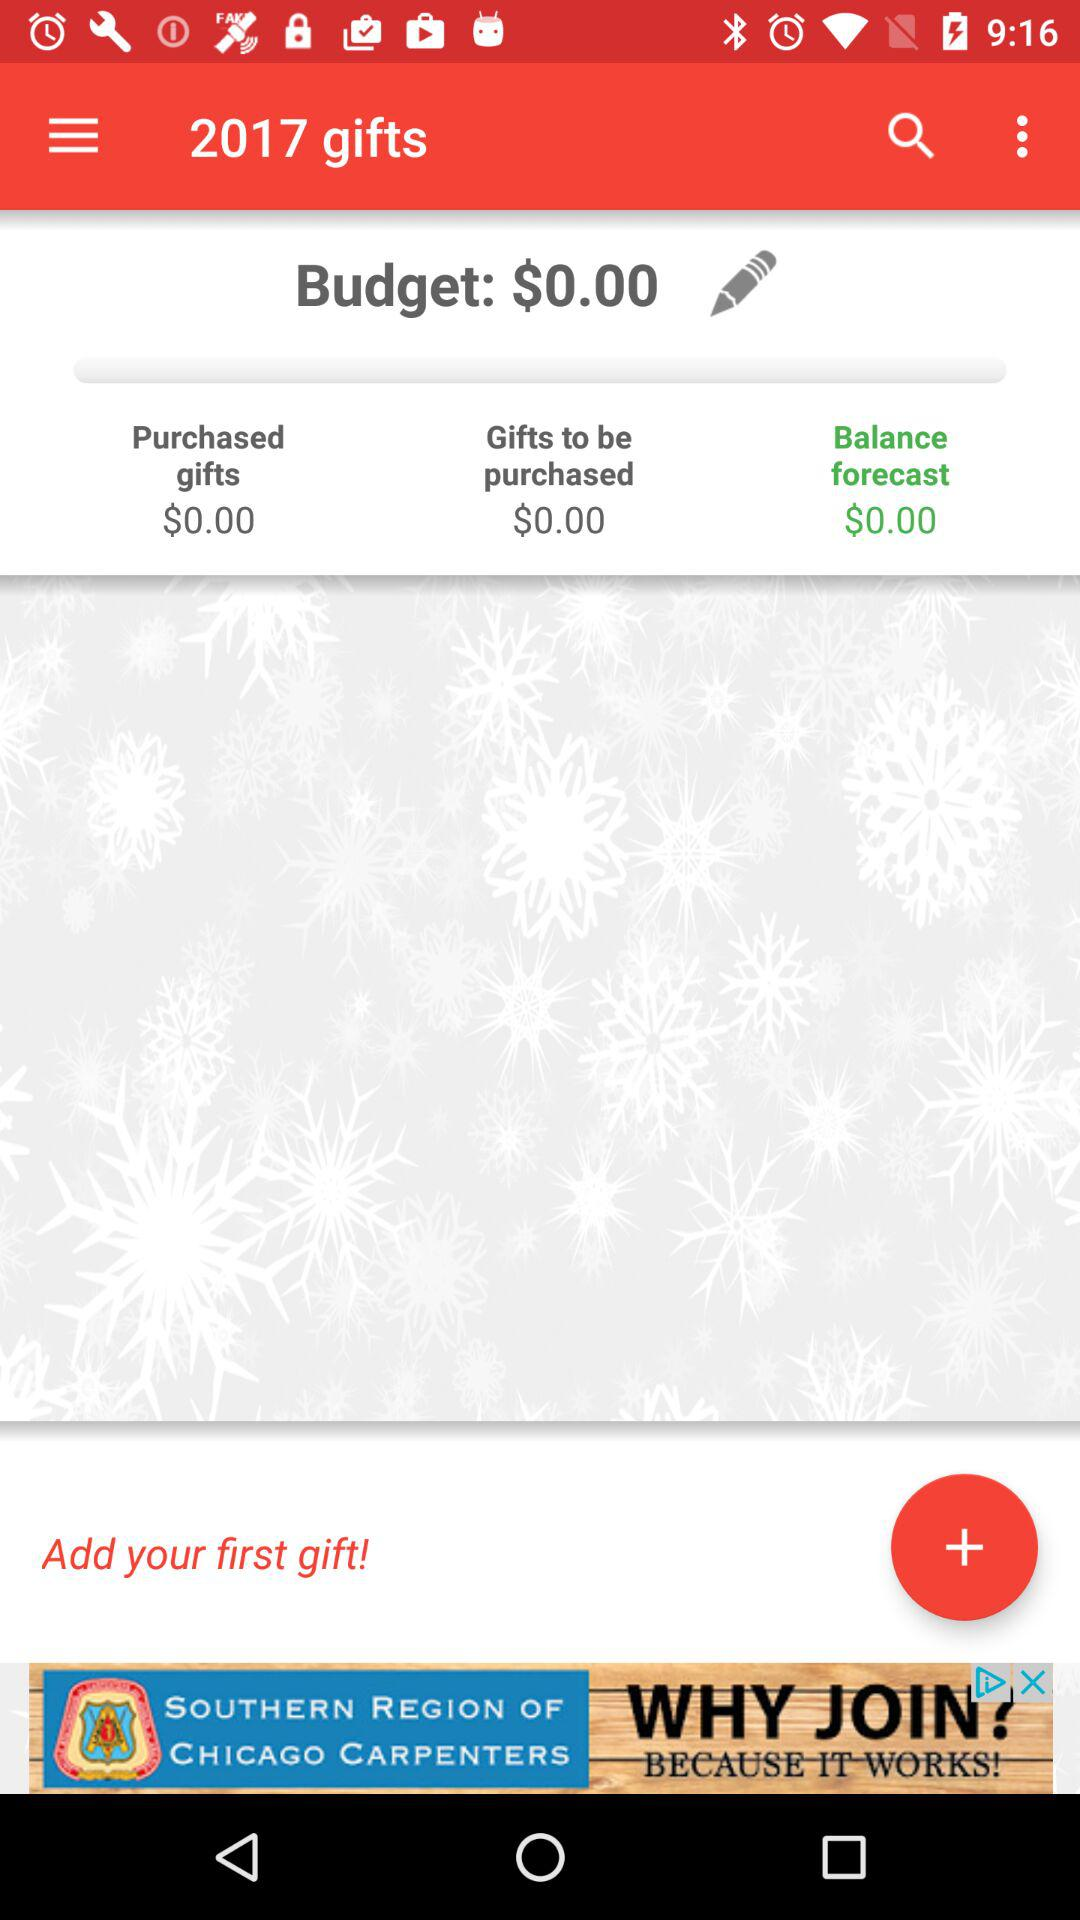When was the first gift added?
When the provided information is insufficient, respond with <no answer>. <no answer> 